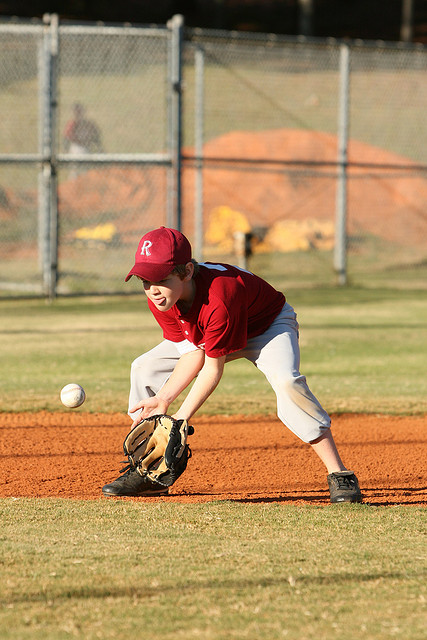Please transcribe the text information in this image. R 